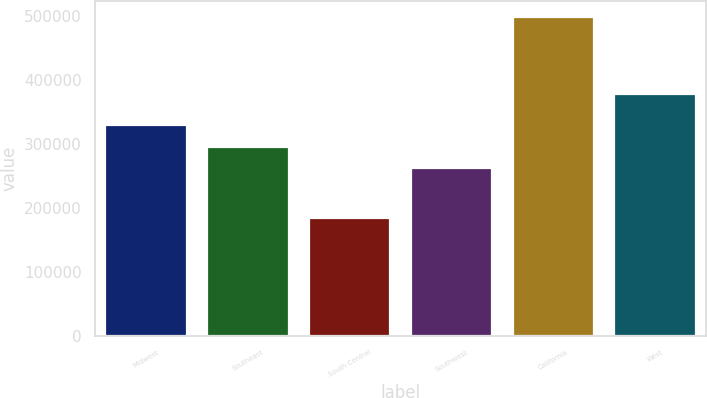Convert chart to OTSL. <chart><loc_0><loc_0><loc_500><loc_500><bar_chart><fcel>Midwest<fcel>Southeast<fcel>South Central<fcel>Southwest<fcel>California<fcel>West<nl><fcel>330000<fcel>295100<fcel>184600<fcel>262900<fcel>498900<fcel>377300<nl></chart> 